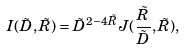<formula> <loc_0><loc_0><loc_500><loc_500>I ( { \tilde { D } } , { \tilde { R } } ) = { \tilde { D } } ^ { 2 - 4 { \tilde { R } } } J ( \frac { \tilde { R } } { \tilde { D } } , { \tilde { R } } ) ,</formula> 